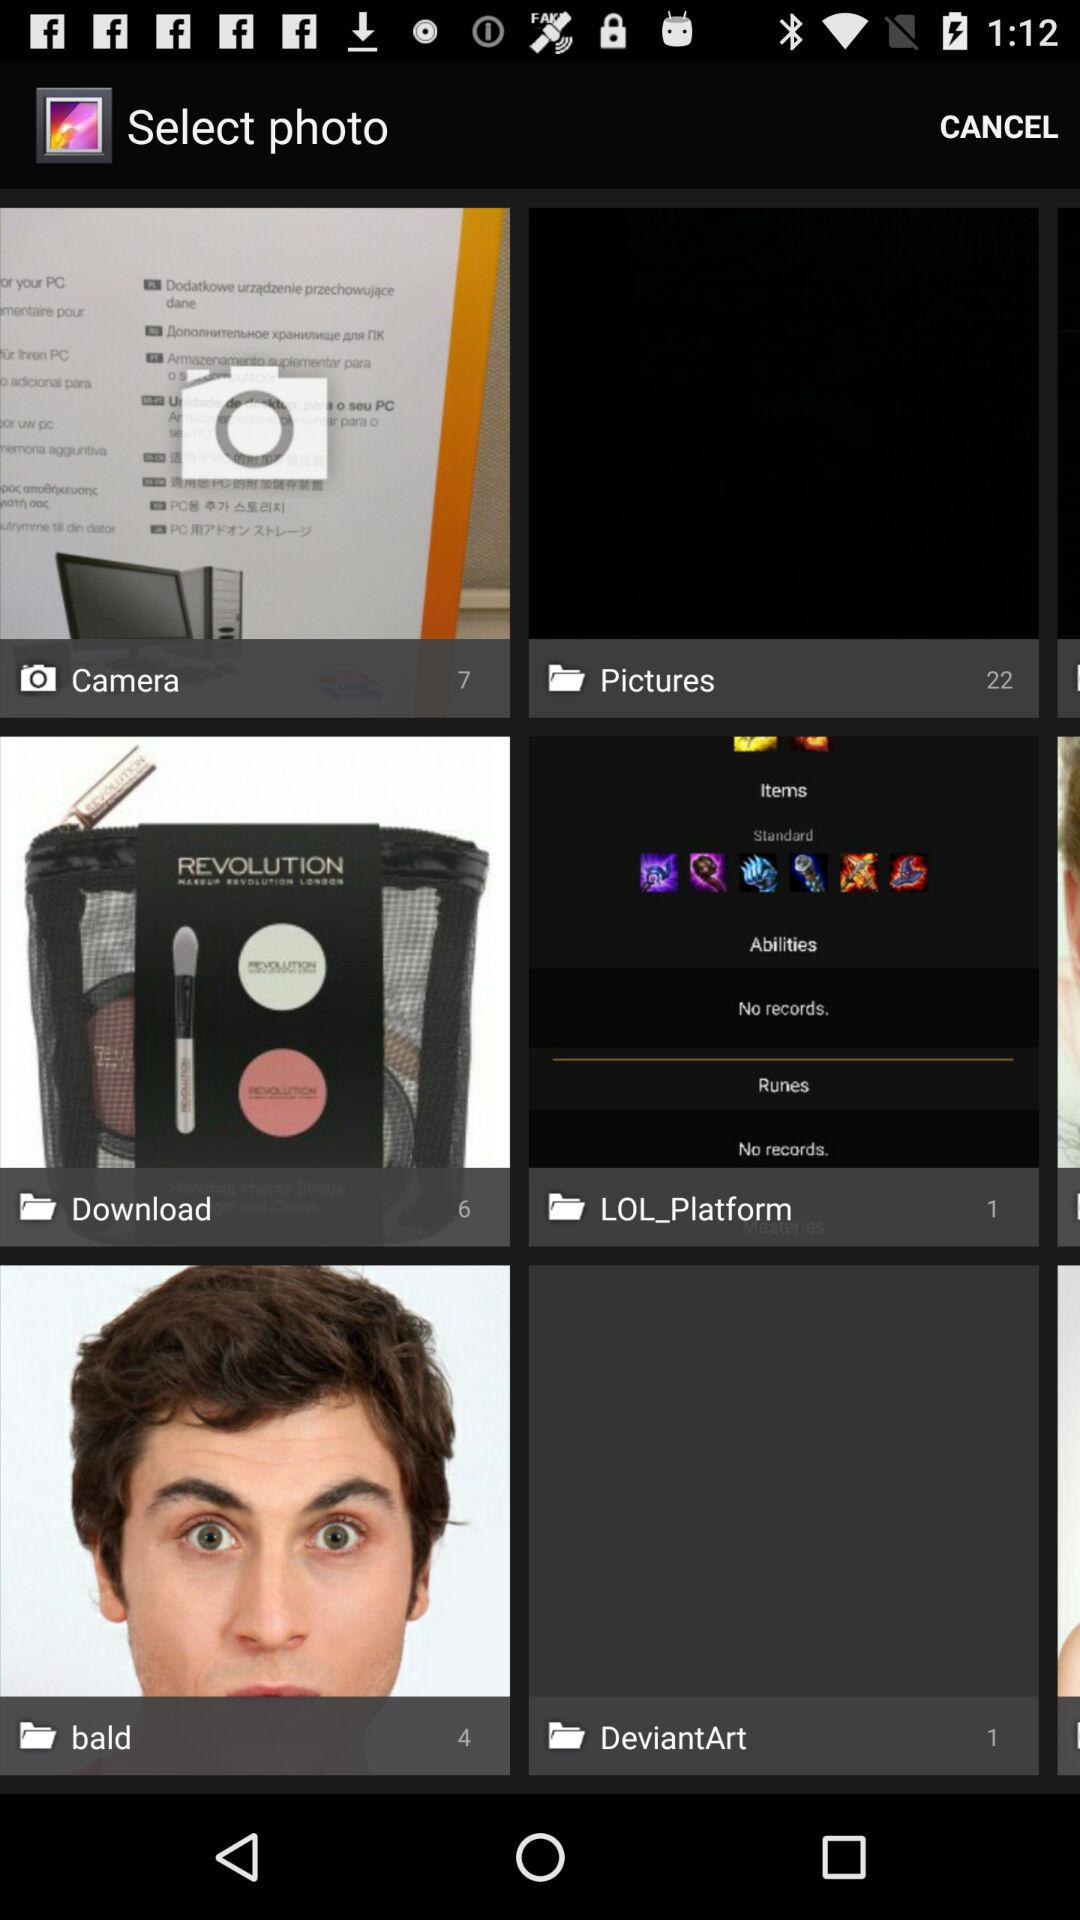What is the number of images in the Bald folder? The number of images is 4. 